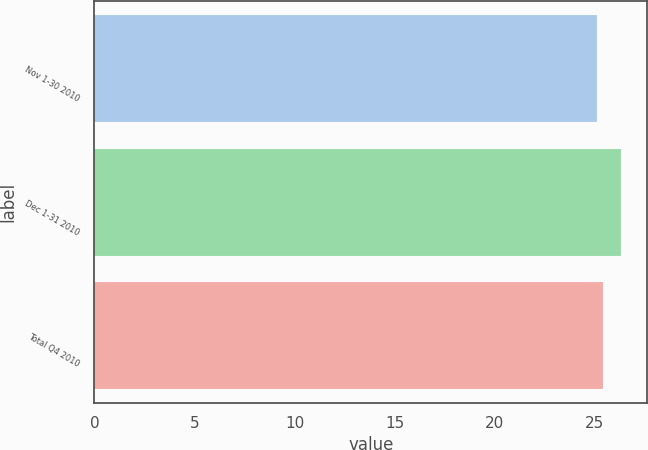Convert chart to OTSL. <chart><loc_0><loc_0><loc_500><loc_500><bar_chart><fcel>Nov 1-30 2010<fcel>Dec 1-31 2010<fcel>Total Q4 2010<nl><fcel>25.11<fcel>26.31<fcel>25.4<nl></chart> 